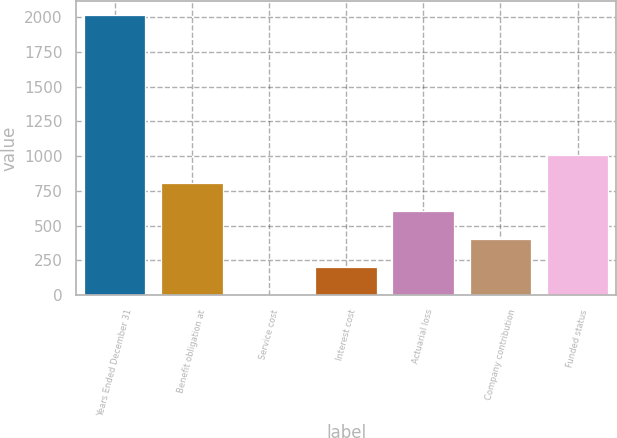Convert chart to OTSL. <chart><loc_0><loc_0><loc_500><loc_500><bar_chart><fcel>Years Ended December 31<fcel>Benefit obligation at<fcel>Service cost<fcel>Interest cost<fcel>Actuarial loss<fcel>Company contribution<fcel>Funded status<nl><fcel>2012<fcel>805.4<fcel>1<fcel>202.1<fcel>604.3<fcel>403.2<fcel>1006.5<nl></chart> 